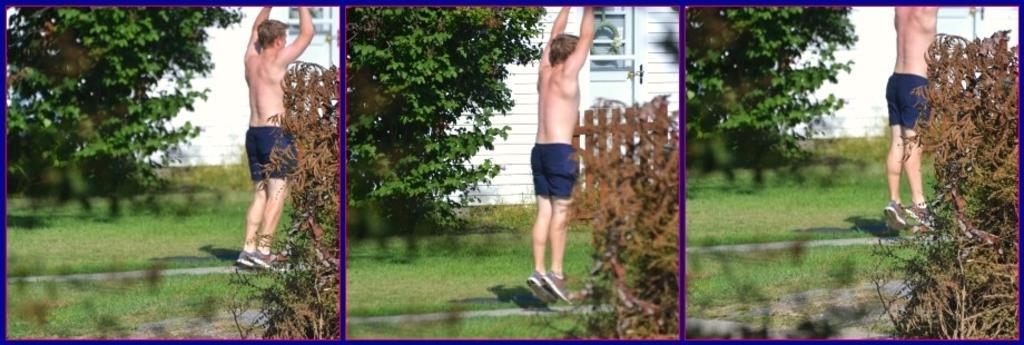How would you summarize this image in a sentence or two? It is the collage of three images. In the images we can see that there is a man who is jumping in the air without the clothes. On the left side there is a tree. Beside the tree there is a house. On the right side bottom there are plants. On the ground there is grass. 